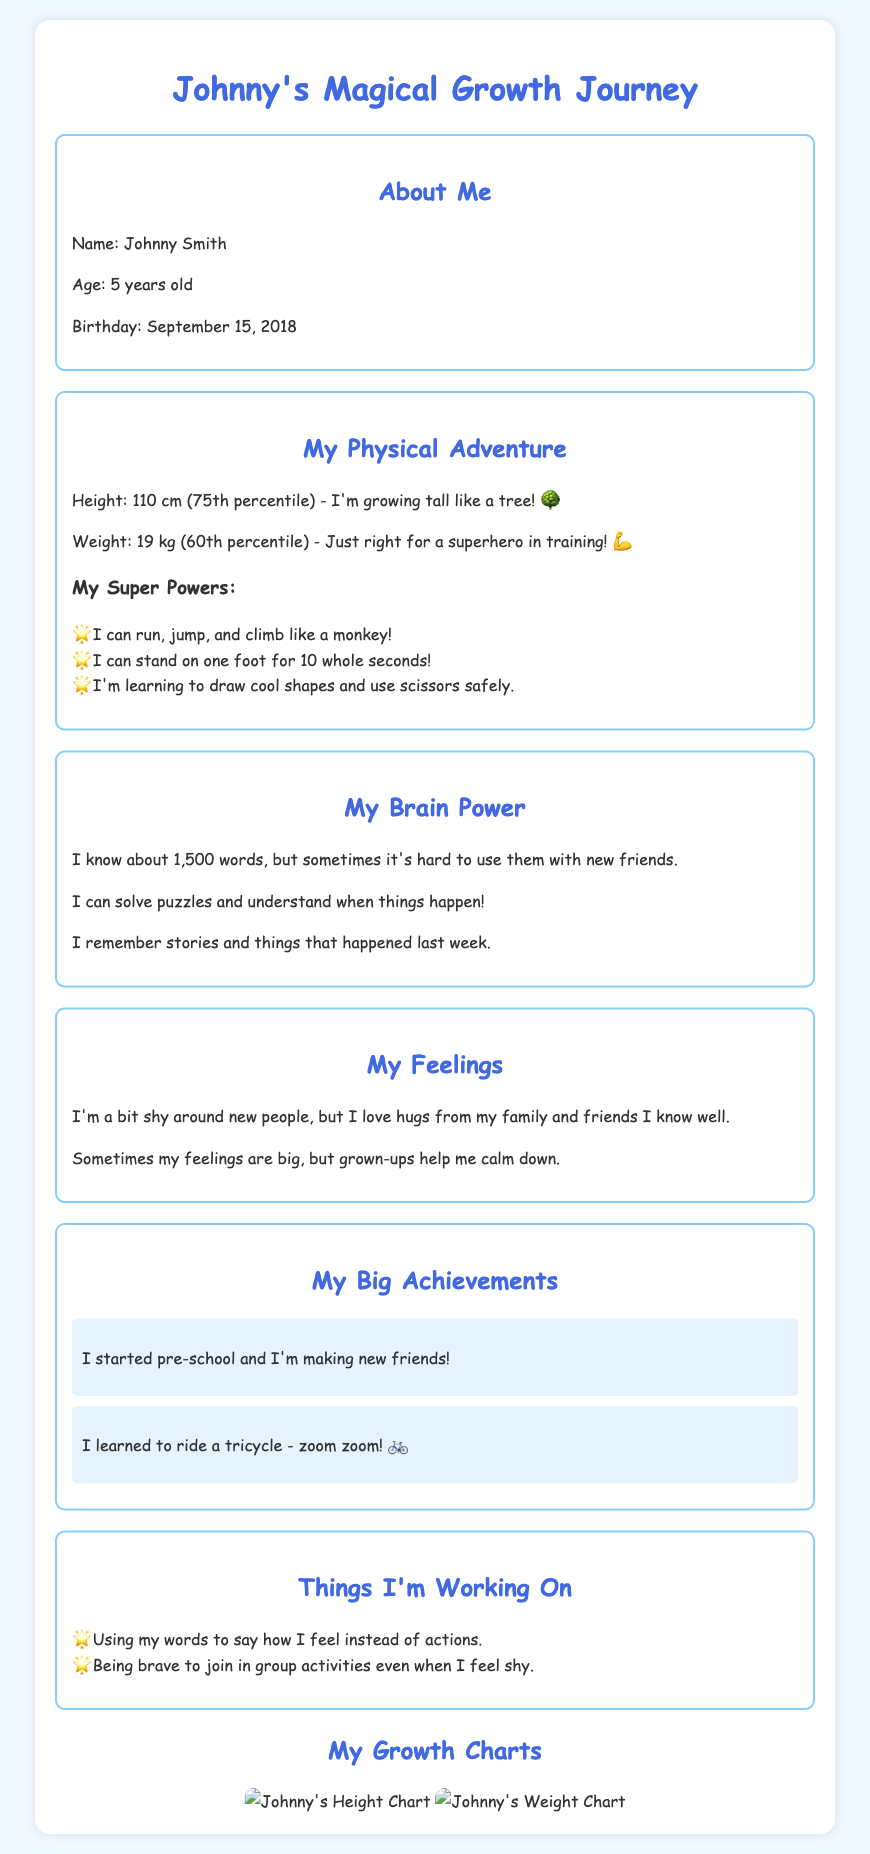What is Johnny's age? Johnny's age is mentioned in the document, which states he is 5 years old.
Answer: 5 years old What is Johnny's height? The document provides Johnny's height as 110 cm in the section about his physical adventure.
Answer: 110 cm What super power can Johnny do? The document lists several physical achievements, including being able to run, jump, and climb like a monkey.
Answer: Run, jump, and climb like a monkey What is Johnny's weight? Johnny's weight is specified as 19 kg in the physical adventure section of the document.
Answer: 19 kg What is one thing Johnny is working on? The document mentions things Johnny is working on, including using his words to express feelings.
Answer: Using words to say how I feel What milestone did Johnny achieve this year? The document outlines Johnny's achievements, one being that he started pre-school.
Answer: Started pre-school How many words does Johnny know? The document states that Johnny knows about 1,500 words.
Answer: 1,500 words What birthday does Johnny celebrate? Johnny's birthday is provided in the document as September 15, 2018.
Answer: September 15, 2018 What percentage is Johnny's weight in? The document mentions that Johnny's weight is in the 60th percentile.
Answer: 60th percentile 